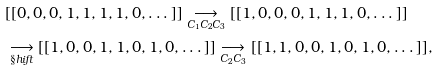<formula> <loc_0><loc_0><loc_500><loc_500>& [ [ 0 , 0 , 0 , 1 , 1 , 1 , 1 , 0 , \dots ] ] \underset { C _ { 1 } C _ { 2 } C _ { 3 } } { \longrightarrow } [ [ 1 , 0 , 0 , 0 , 1 , 1 , 1 , 0 , \dots ] ] \\ & \underset { \S h i f t } { \longrightarrow } [ [ 1 , 0 , 0 , 1 , 1 , 0 , 1 , 0 , \dots ] ] \underset { C _ { 2 } C _ { 3 } } { \longrightarrow } [ [ 1 , 1 , 0 , 0 , 1 , 0 , 1 , 0 , \dots ] ] ,</formula> 